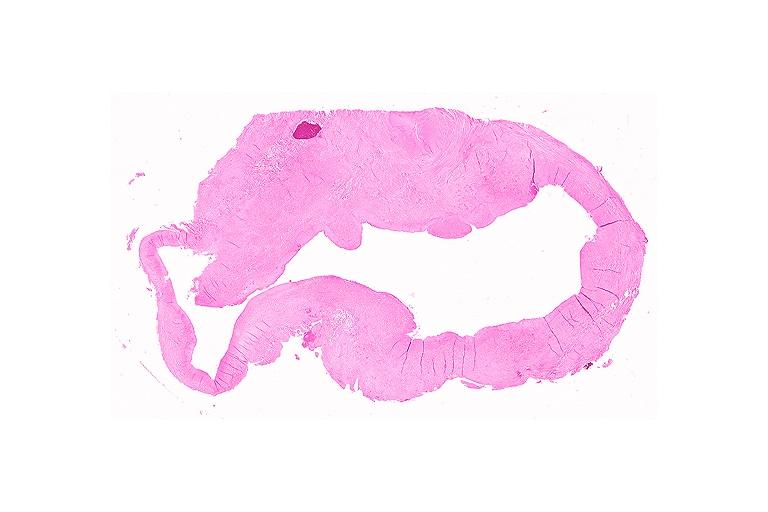s oral present?
Answer the question using a single word or phrase. Yes 